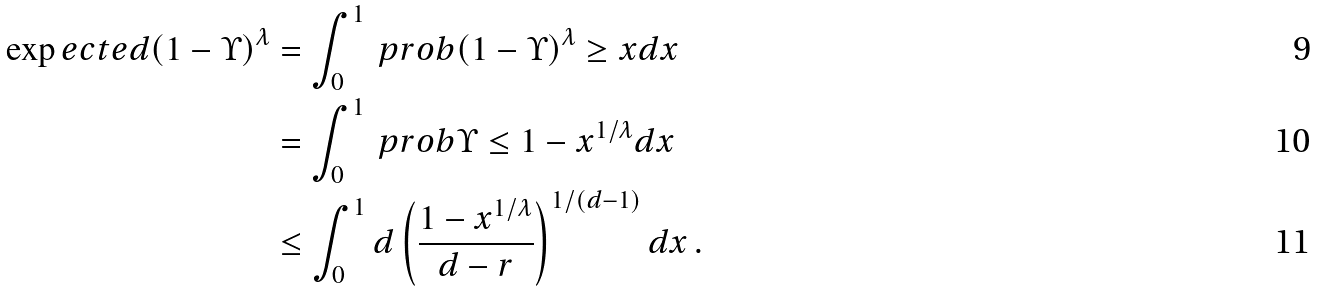<formula> <loc_0><loc_0><loc_500><loc_500>\exp e c t e d { \left ( 1 - \Upsilon \right ) ^ { \lambda } } & = \int _ { 0 } ^ { 1 } \ p r o b { \left ( 1 - \Upsilon \right ) ^ { \lambda } \geq x } d x \\ & = \int _ { 0 } ^ { 1 } \ p r o b { \Upsilon \leq 1 - x ^ { 1 / \lambda } } d x \\ & \leq \int _ { 0 } ^ { 1 } d \left ( \frac { 1 - x ^ { 1 / \lambda } } { d - r } \right ) ^ { 1 / ( d - 1 ) } d x \, .</formula> 